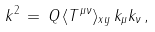<formula> <loc_0><loc_0><loc_500><loc_500>k ^ { 2 } \, = \, Q \, \langle T ^ { \mu \nu } \rangle _ { x y } \, k _ { \mu } k _ { \nu } \, ,</formula> 